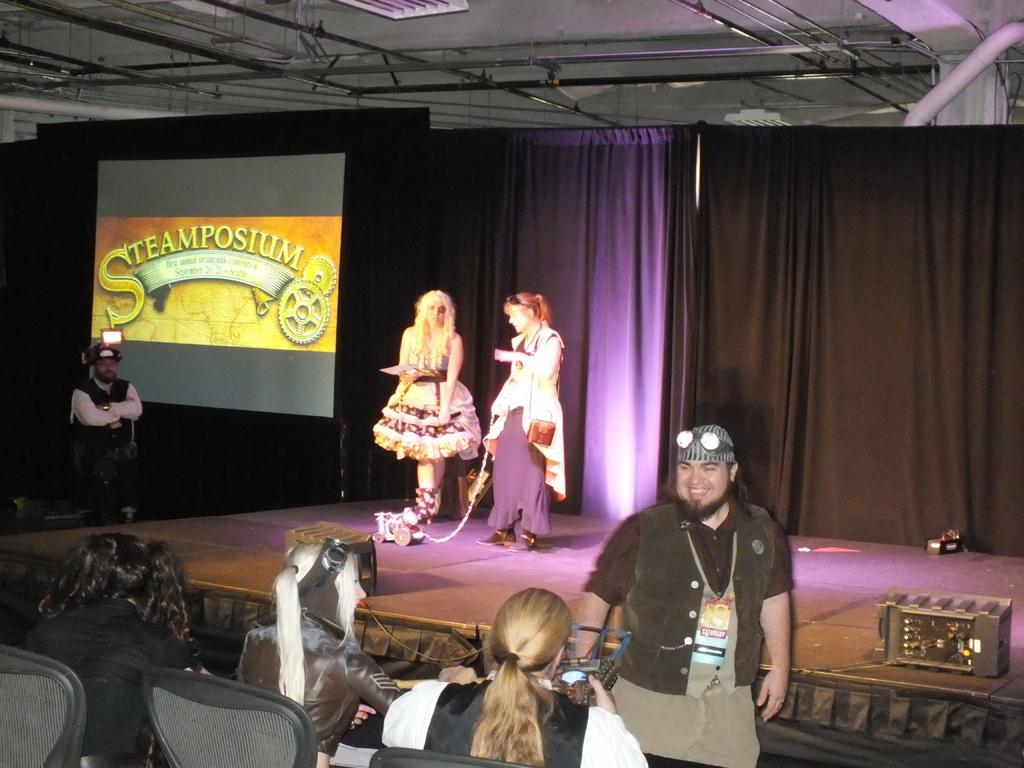How would you summarize this image in a sentence or two? As we can see in the image there are few people here and there, curtains, screen and chair. 